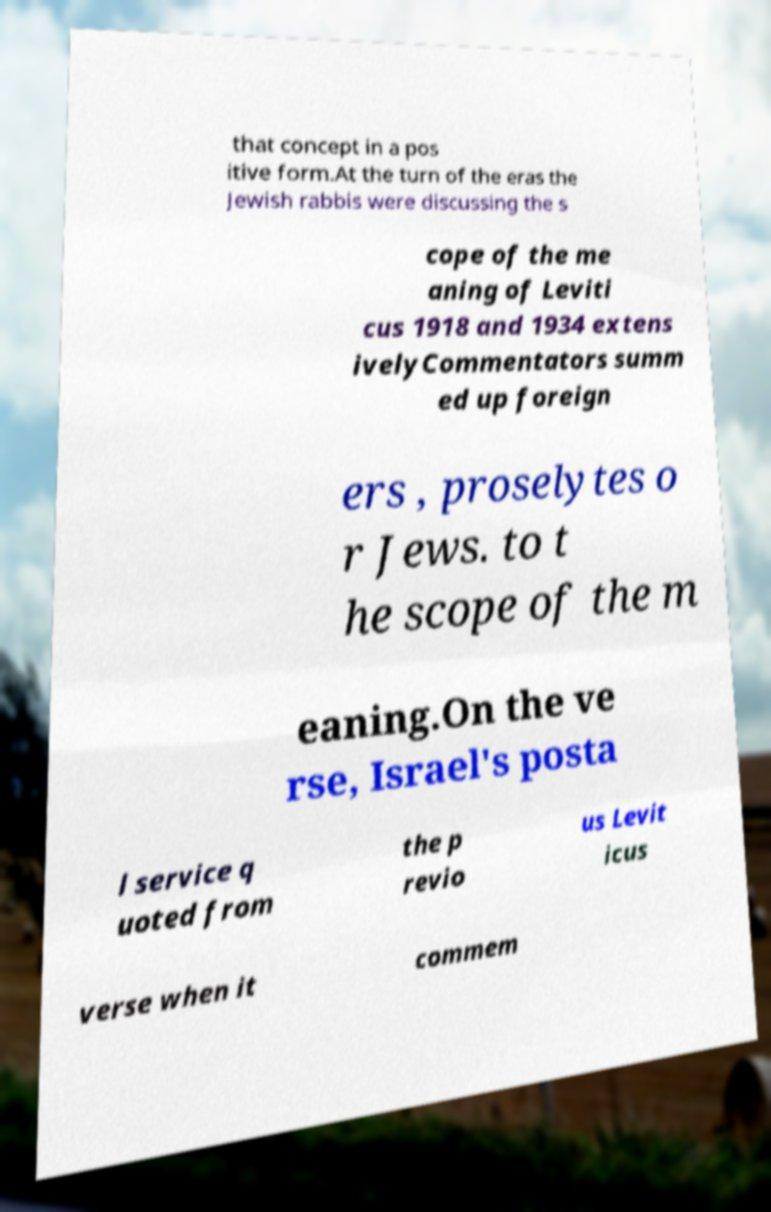What messages or text are displayed in this image? I need them in a readable, typed format. that concept in a pos itive form.At the turn of the eras the Jewish rabbis were discussing the s cope of the me aning of Leviti cus 1918 and 1934 extens ivelyCommentators summ ed up foreign ers , proselytes o r Jews. to t he scope of the m eaning.On the ve rse, Israel's posta l service q uoted from the p revio us Levit icus verse when it commem 